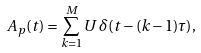Convert formula to latex. <formula><loc_0><loc_0><loc_500><loc_500>A _ { p } ( t ) = \sum _ { k = 1 } ^ { M } U \, \delta ( t - ( k - 1 ) \tau ) ,</formula> 